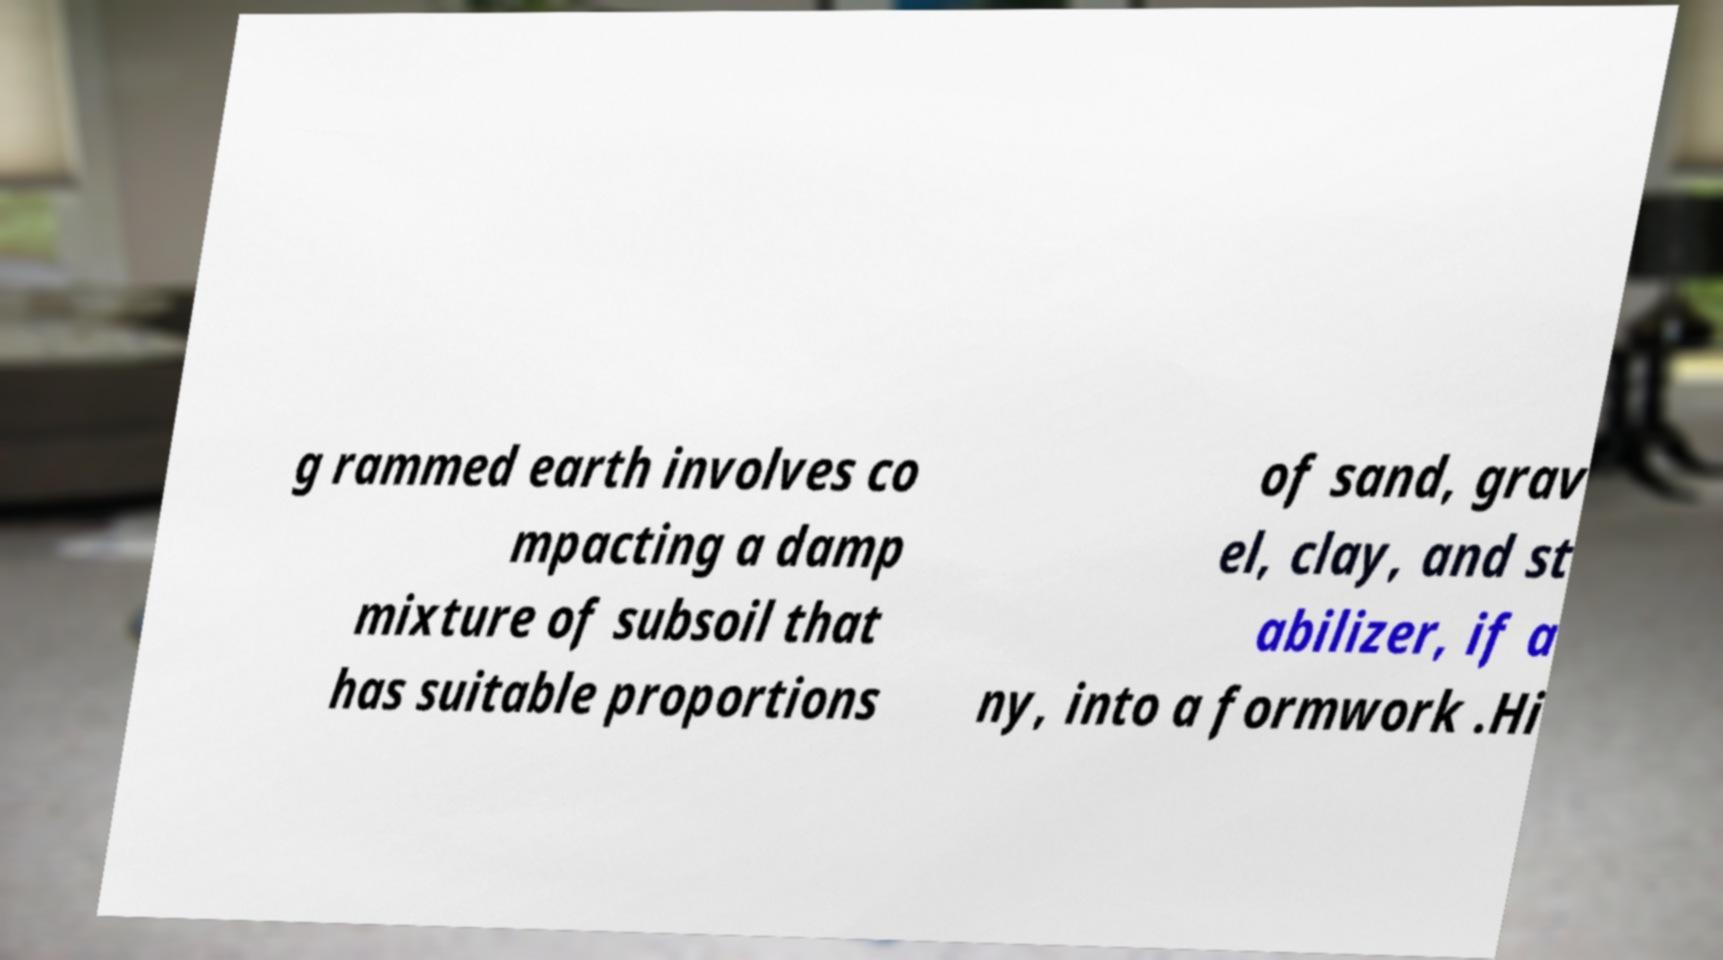For documentation purposes, I need the text within this image transcribed. Could you provide that? g rammed earth involves co mpacting a damp mixture of subsoil that has suitable proportions of sand, grav el, clay, and st abilizer, if a ny, into a formwork .Hi 